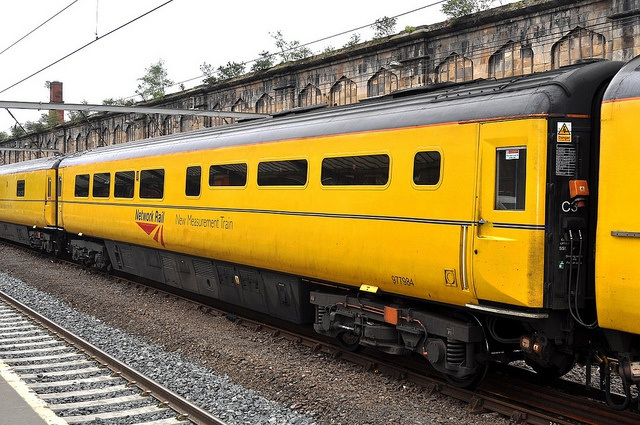Describe the objects in this image and their specific colors. I can see a train in white, black, orange, gold, and gray tones in this image. 